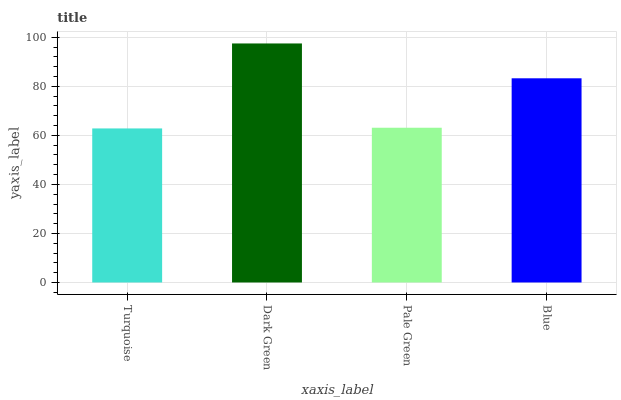Is Turquoise the minimum?
Answer yes or no. Yes. Is Dark Green the maximum?
Answer yes or no. Yes. Is Pale Green the minimum?
Answer yes or no. No. Is Pale Green the maximum?
Answer yes or no. No. Is Dark Green greater than Pale Green?
Answer yes or no. Yes. Is Pale Green less than Dark Green?
Answer yes or no. Yes. Is Pale Green greater than Dark Green?
Answer yes or no. No. Is Dark Green less than Pale Green?
Answer yes or no. No. Is Blue the high median?
Answer yes or no. Yes. Is Pale Green the low median?
Answer yes or no. Yes. Is Turquoise the high median?
Answer yes or no. No. Is Blue the low median?
Answer yes or no. No. 